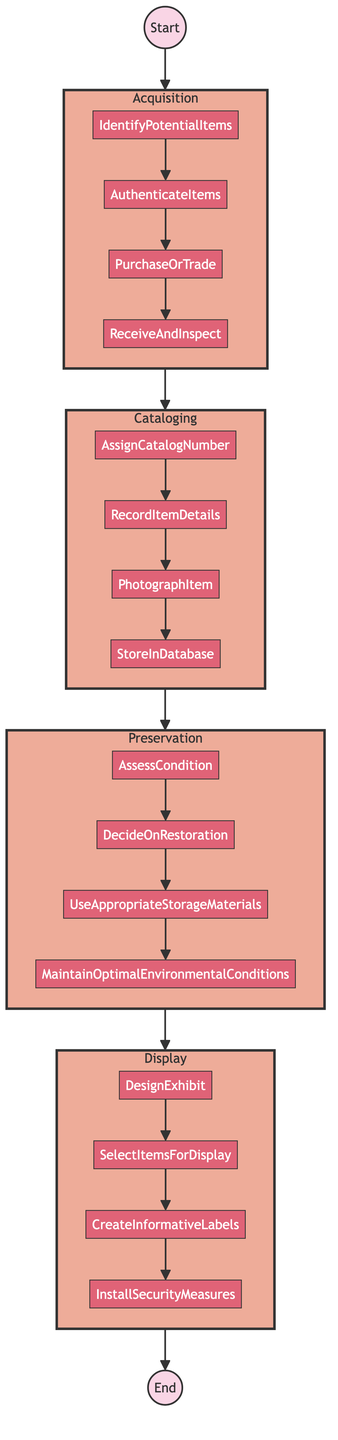What's the first step in the function? The first step in the flowchart is labeled "Acquisition," which indicates the initial phase of cataloging and preserving film memorabilia.
Answer: Acquisition How many main steps are there in the process? The flowchart outlines a total of four main steps: Acquisition, Cataloging, Preservation, and Display.
Answer: Four What is the last action in the Acquisition step? The last action listed in the Acquisition subgraph is "ReceiveAndInspect," which indicates the final task performed during this phase.
Answer: ReceiveAndInspect Which main step comes after Cataloging? Following the Cataloging step, the next main step in the flowchart is Preservation, indicating the actions taken for item longevity.
Answer: Preservation What action follows "AssessCondition" in the Preservation step? After "AssessCondition," the next action is "DecideOnRestoration," which is the subsequent task in the Preservation subgraph.
Answer: DecideOnRestoration How many actions are there in the Display step? The Display step consists of four actions: "DesignExhibit," "SelectItemsForDisplay," "CreateInformativeLabels," and "InstallSecurityMeasures."
Answer: Four What is the relationship between "PurchaseOrTrade" and "Cataloging"? "PurchaseOrTrade" is the last action in the Acquisition step, and after completing this action, the process moves to the Cataloging step, indicating a direct flow from one step to the next.
Answer: Moves to Cataloging What action is related to labeling in the Display step? The action specifically related to labeling in the Display step is "CreateInformativeLabels," which involves providing information about the displayed items.
Answer: CreateInformativeLabels What is the first action of the Cataloging step? The first action within the Cataloging step is "AssignCatalogNumber," which marks the beginning of the cataloging process for each film memorabilia item.
Answer: AssignCatalogNumber 